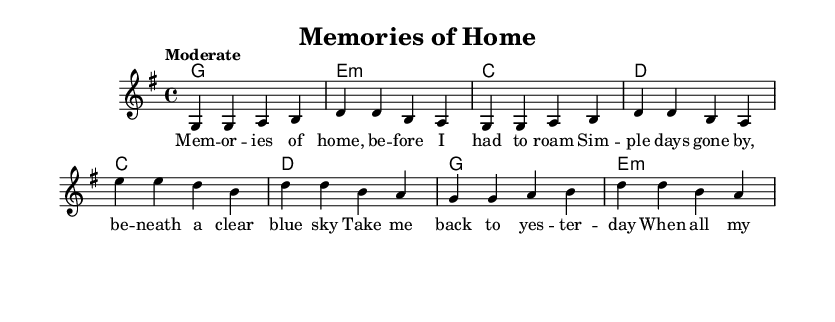What is the key signature of this music? The key signature is G major, which has one sharp (F#). This is indicated by the presence of the key signature shown at the beginning of the staff.
Answer: G major What is the time signature of this piece? The time signature is 4/4, which is common in popular music genres. This can be seen at the beginning of the staff where the time is indicated.
Answer: 4/4 What is the tempo marking for the music? The tempo is marked as "Moderate," which suggests a comfortable pace suitable for a nostalgic piece. It is indicated above the staff.
Answer: Moderate How many measures are in the verse? The verse contains four measures, as indicated by the four groups of notes and bars in the verse section of the notation.
Answer: Four What style of music is this piece? This piece is classified as Rhythm and Blues, a genre that blends soulful melodies and grooves, as suggested by the structure and lyrical content focused on nostalgia.
Answer: Rhythm and Blues What is the lyric theme of the chorus? The chorus reflects a longing for the past, expressing a desire to return to simpler times. The lyrics refer to yesterday and the fading of cares. This theme is evident through the words provided.
Answer: Nostalgia for the past 